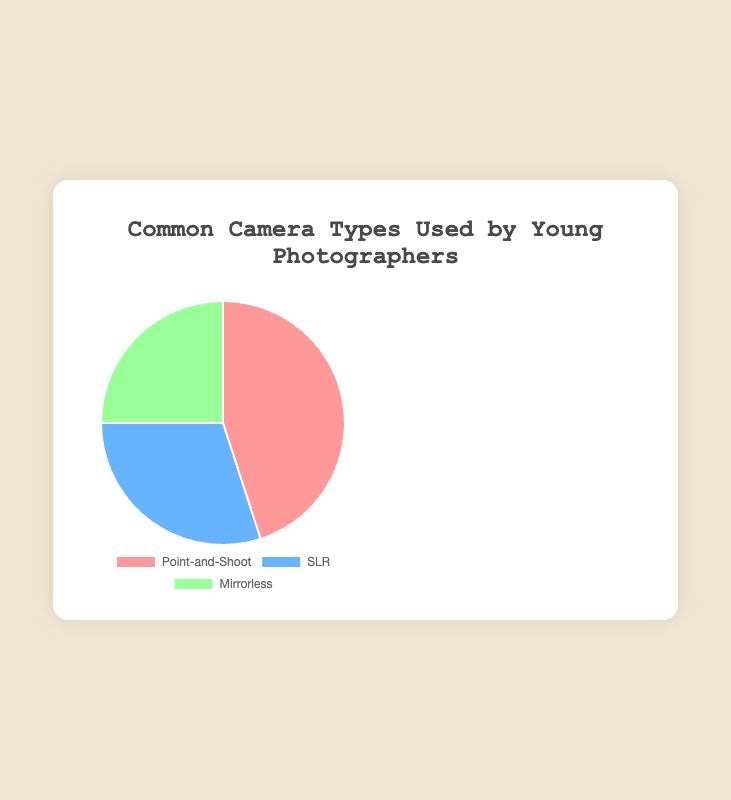What is the most common camera type used by young photographers? The largest section of the pie chart represents Point-and-Shoot cameras, indicating it is the most common.
Answer: Point-and-Shoot Which camera type is used the least by young photographers? The smallest section of the pie chart represents Mirrorless cameras, indicating it is the least common.
Answer: Mirrorless How much more popular are Point-and-Shoot cameras compared to Mirrorless cameras in percentage? Subtract the percentage of Mirrorless cameras from Point-and-Shoot: 45% - 25% = 20%.
Answer: 20% What is the combined percentage of users for SLR and Mirrorless cameras? Add the percentages of SLR and Mirrorless cameras: 30% + 25% = 55%.
Answer: 55% What color represents SLR cameras in the pie chart? The section representing SLR cameras is colored blue.
Answer: Blue By how much percentage is Point-and-Shoot preferred over SLR? Subtract the percentage of SLR from Point-and-Shoot: 45% - 30% = 15%.
Answer: 15% Which two camera types combined have the same percentage as Point-and-Shoot cameras alone? The combined percentage of SLR and Mirrorless cameras is 30% + 25% = 55%, which is more than Point-and-Shoot. However, no pair adds exactly to 45%, so this question is misleading.
Answer: None Are there more users of SLR cameras or Mirrorless cameras? The section representing SLR cameras is larger than the section representing Mirrorless cameras, indicating more users.
Answer: SLR What is the average percentage use across all three camera types? Calculate the average: (45% + 30% + 25%) / 3 = 33.33%.
Answer: 33.33% Which camera type's section appears green in the pie chart? The section representing Mirrorless cameras is colored green.
Answer: Mirrorless 